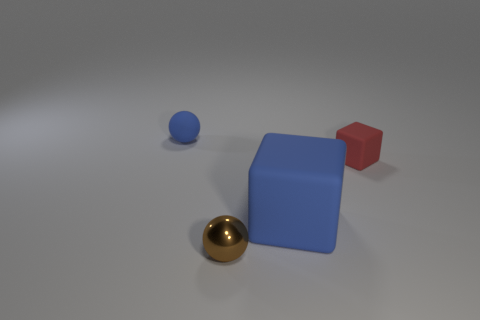Add 3 red rubber things. How many red rubber things are left? 4 Add 4 purple balls. How many purple balls exist? 4 Add 3 red rubber cubes. How many objects exist? 7 Subtract 0 cyan cubes. How many objects are left? 4 Subtract 2 cubes. How many cubes are left? 0 Subtract all purple blocks. Subtract all cyan cylinders. How many blocks are left? 2 Subtract all yellow cylinders. How many blue blocks are left? 1 Subtract all small matte cubes. Subtract all tiny brown metallic things. How many objects are left? 2 